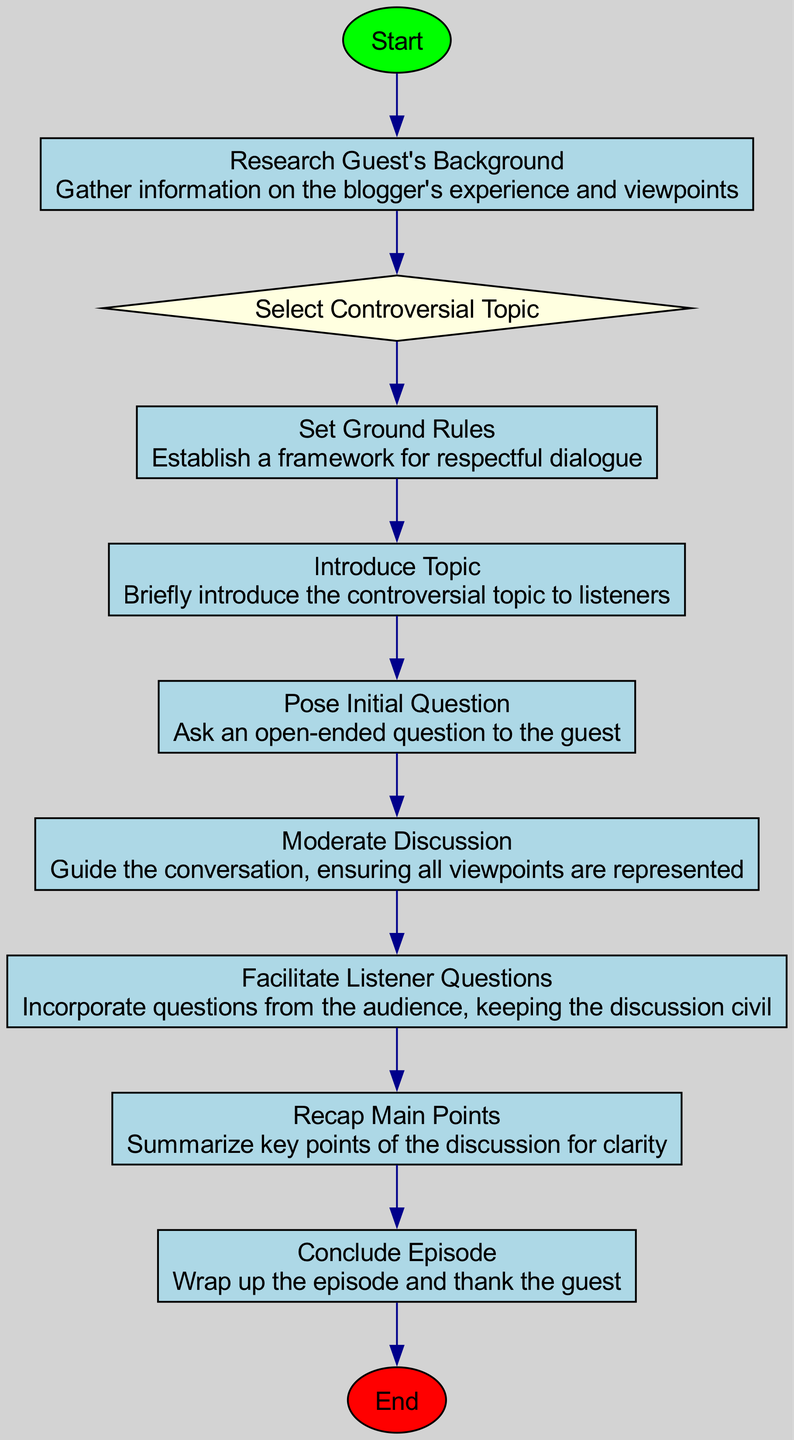What is the first step in the podcast host workflow? The first step is clearly indicated in the diagram as "Initiate Podcast Episode", which is the starting point of the entire flow.
Answer: Initiate Podcast Episode What type of element is "Select Controversial Topic"? In the diagram, the element "Select Controversial Topic" is represented as a decision node, characterized by its diamond shape as noted in the diagram's structure.
Answer: decision How many total process nodes are present in the workflow? The workflow consists of several nodes, and by counting the elements that are labeled as processes, we find there are six process nodes numbered 1, 3, 4, 5, 6, 8, and 9.
Answer: six Which node follows the "Set Ground Rules"? The direction of the arrows in the diagram indicates that the node directly following "Set Ground Rules" is "Introduce Topic", showing a clear flow from the former to the latter.
Answer: Introduce Topic What is the last action taken in the flowchart? The final action in the flowchart is "Conclude Episode" which evidently wraps up the podcast proceedings as shown at the end of the diagram.
Answer: Conclude Episode How many connections lead out of the "Moderate Discussion" node? The "Moderate Discussion" node has one outgoing connection leading to the "Facilitate Listener Questions" node, as demonstrated by the diagram's directed edges.
Answer: one What is the connection between "Pose Initial Question" and "Moderate Discussion"? The diagram shows that "Pose Initial Question" is connected directly to "Moderate Discussion" with an edge, indicating a sequential relationship where asking an initial question leads to the moderation of the ensuing discussion.
Answer: direct connection What is the purpose of the "Recap Main Points" node in the workflow? The "Recap Main Points" node serves the function of summarizing the key discussion points to enhance listener clarity and understanding, as described in the element's details.
Answer: summarize key points 